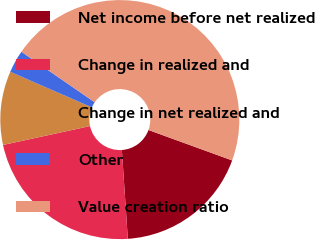Convert chart. <chart><loc_0><loc_0><loc_500><loc_500><pie_chart><fcel>Net income before net realized<fcel>Change in realized and<fcel>Change in net realized and<fcel>Other<fcel>Value creation ratio<nl><fcel>18.38%<fcel>22.66%<fcel>9.95%<fcel>3.06%<fcel>45.94%<nl></chart> 